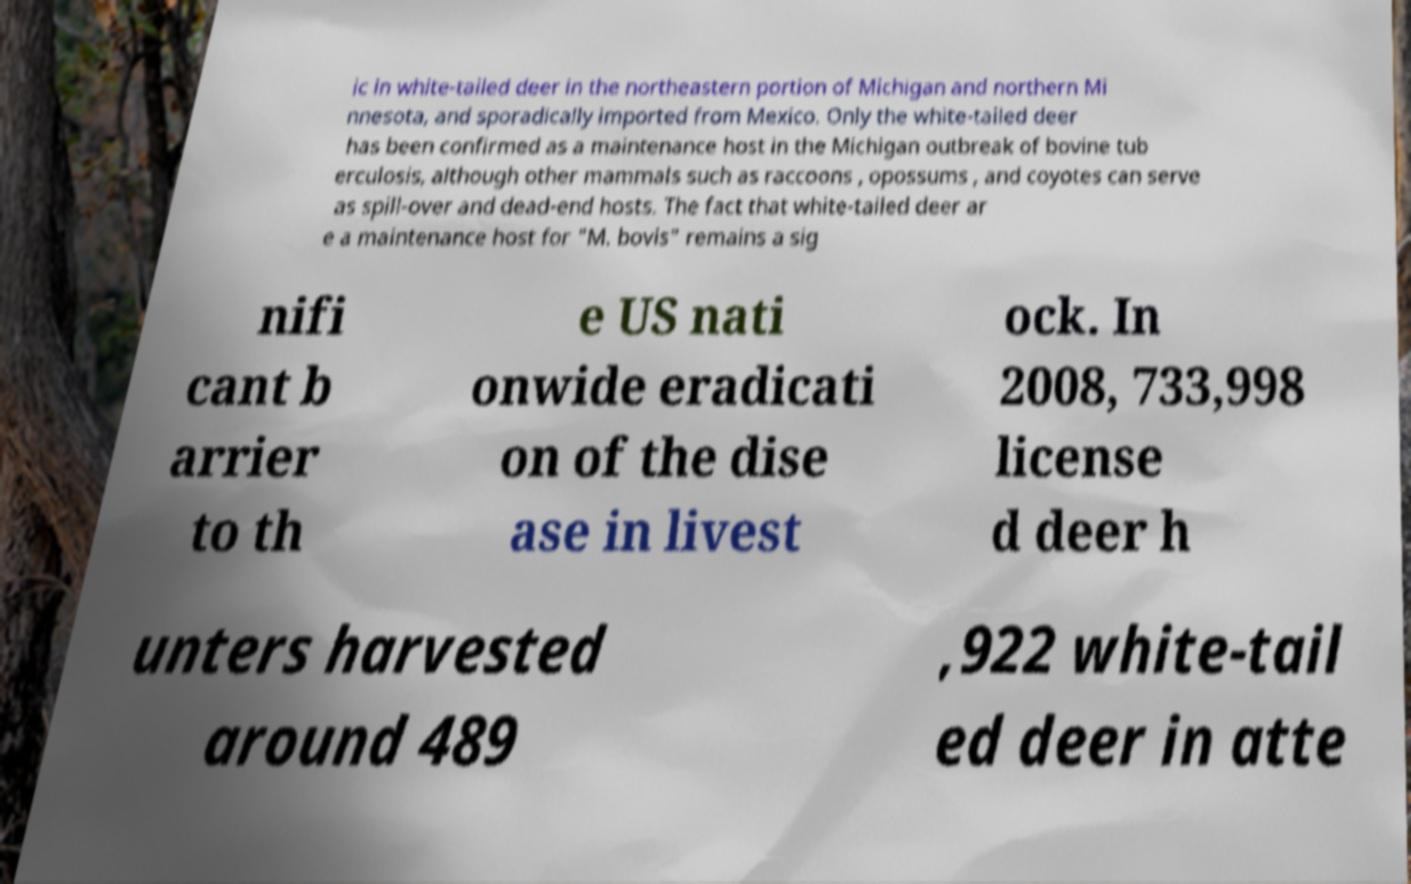Can you read and provide the text displayed in the image?This photo seems to have some interesting text. Can you extract and type it out for me? ic in white-tailed deer in the northeastern portion of Michigan and northern Mi nnesota, and sporadically imported from Mexico. Only the white-tailed deer has been confirmed as a maintenance host in the Michigan outbreak of bovine tub erculosis, although other mammals such as raccoons , opossums , and coyotes can serve as spill-over and dead-end hosts. The fact that white-tailed deer ar e a maintenance host for "M. bovis" remains a sig nifi cant b arrier to th e US nati onwide eradicati on of the dise ase in livest ock. In 2008, 733,998 license d deer h unters harvested around 489 ,922 white-tail ed deer in atte 